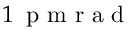<formula> <loc_0><loc_0><loc_500><loc_500>1 \, p m r a d</formula> 